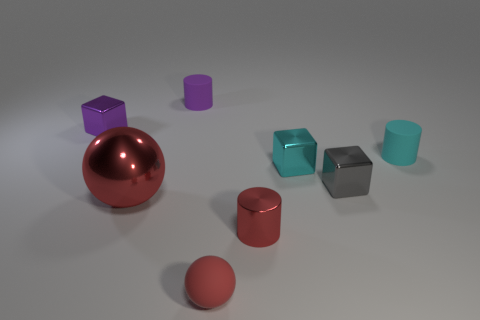Subtract all tiny metal cylinders. How many cylinders are left? 2 Add 1 gray metal blocks. How many objects exist? 9 Subtract 0 brown cylinders. How many objects are left? 8 Subtract all cubes. How many objects are left? 5 Subtract 1 balls. How many balls are left? 1 Subtract all cyan balls. Subtract all cyan cylinders. How many balls are left? 2 Subtract all brown spheres. How many cyan cubes are left? 1 Subtract all big brown rubber cubes. Subtract all large red metal balls. How many objects are left? 7 Add 2 tiny purple objects. How many tiny purple objects are left? 4 Add 6 cyan cubes. How many cyan cubes exist? 7 